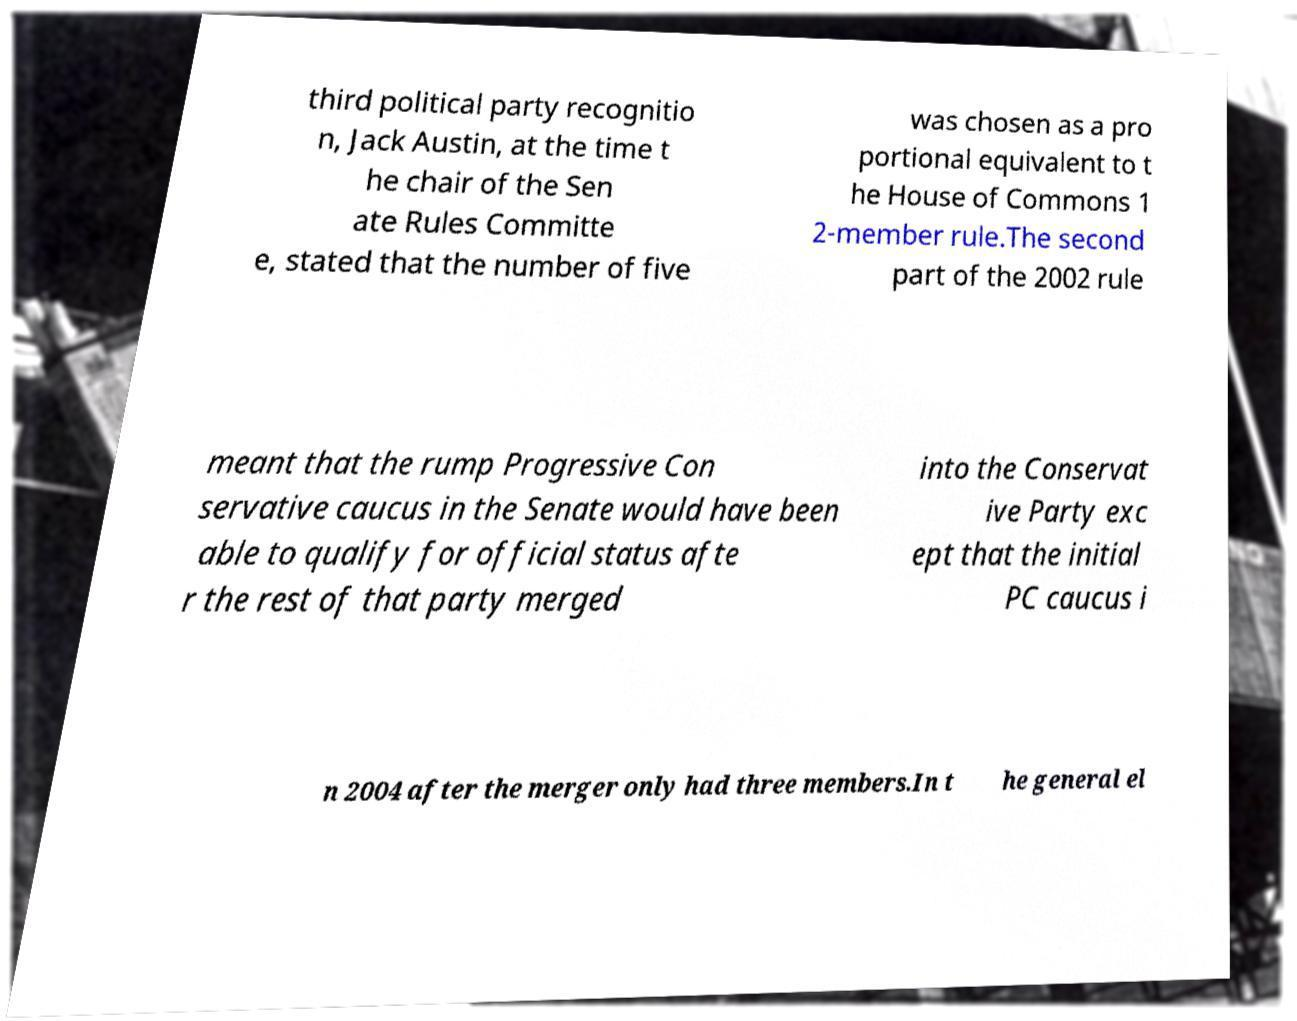I need the written content from this picture converted into text. Can you do that? third political party recognitio n, Jack Austin, at the time t he chair of the Sen ate Rules Committe e, stated that the number of five was chosen as a pro portional equivalent to t he House of Commons 1 2-member rule.The second part of the 2002 rule meant that the rump Progressive Con servative caucus in the Senate would have been able to qualify for official status afte r the rest of that party merged into the Conservat ive Party exc ept that the initial PC caucus i n 2004 after the merger only had three members.In t he general el 